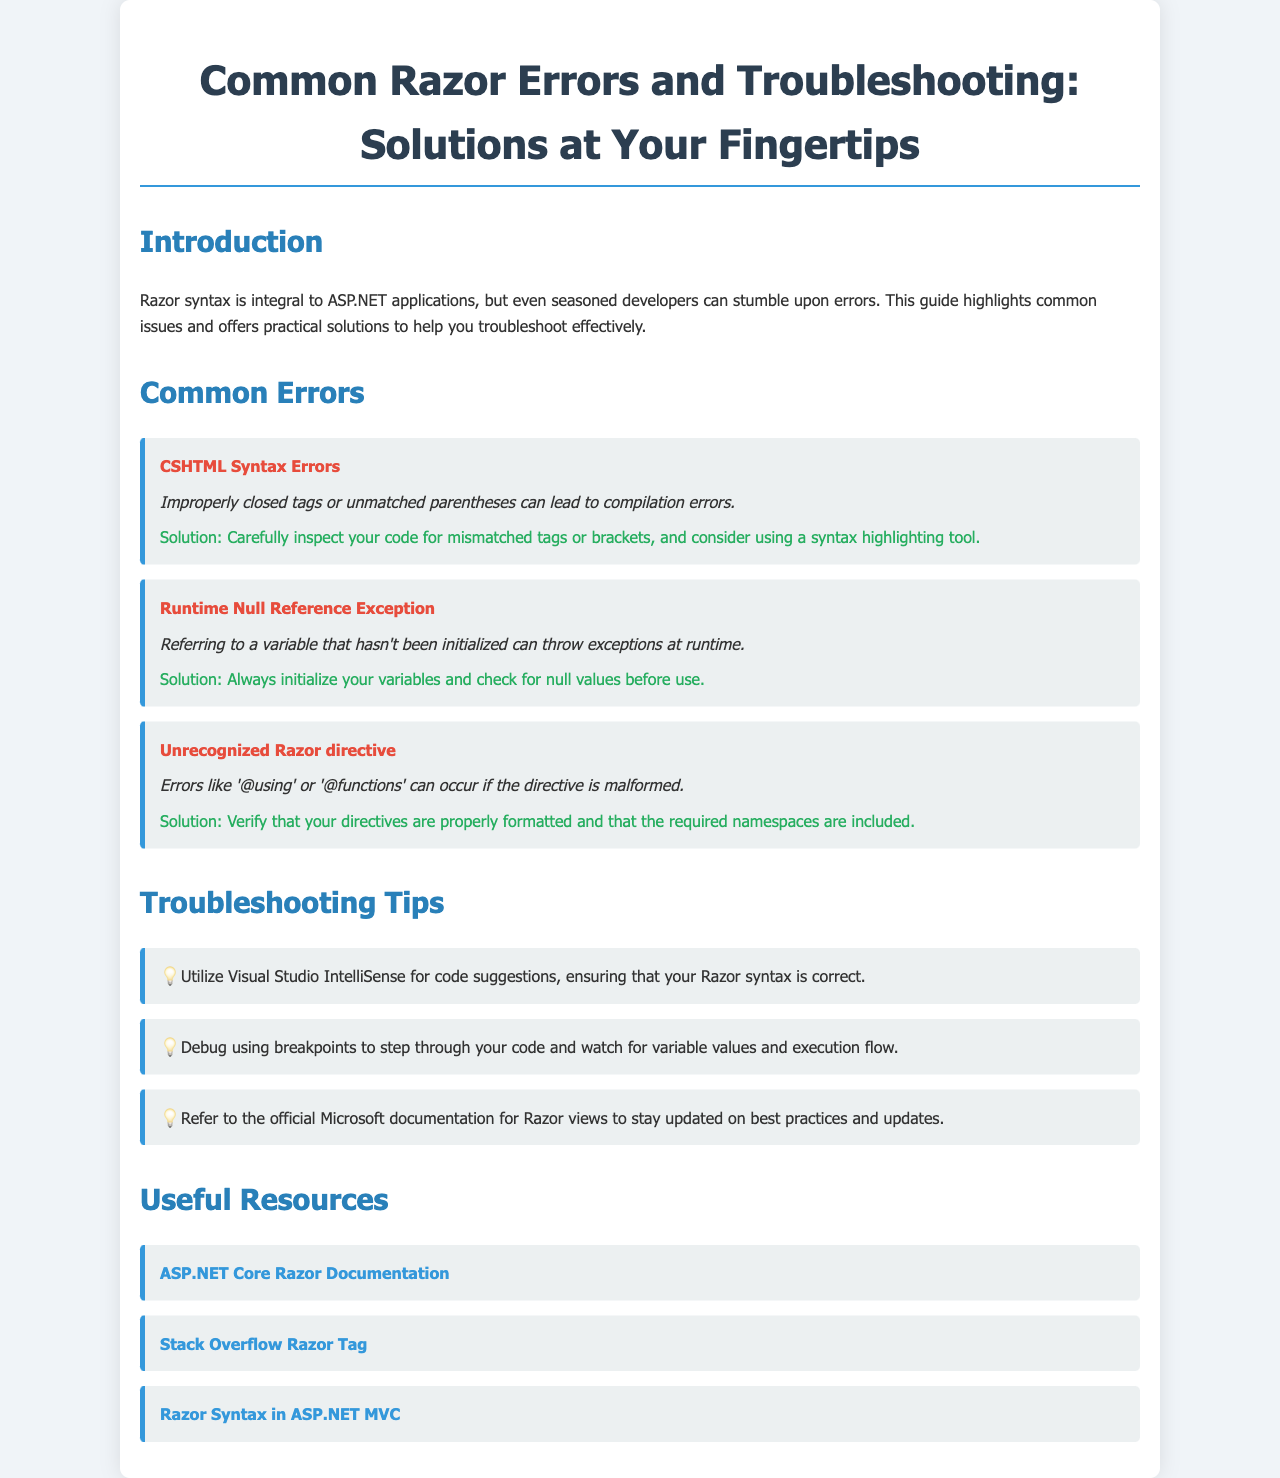What is the title of the brochure? The title is prominently displayed at the top of the document and summarizes the content covered.
Answer: Common Razor Errors and Troubleshooting: Solutions at Your Fingertips What is a common error related to CSHTML? The document lists specific errors under "Common Errors," including multiple examples.
Answer: CSHTML Syntax Errors What is a solution for a Runtime Null Reference Exception? The document suggests specific remedies for runtime errors, including variable management.
Answer: Always initialize your variables and check for null values before use What type of documentation is suggested for Razor views? The document refers to resources that provide further information and support for Razor syntax.
Answer: Official Microsoft documentation How many common errors are listed? The "Common Errors" section provides a specific number of errors discussed within the document.
Answer: Three What symbol is used to denote tips in the troubleshooting section? The document features a visual indicator for tips, enhancing readability and organization.
Answer: 💡 Which online platform is mentioned as a resource for Razor questions? The document lists several useful resources, among which one is a widely known platform.
Answer: Stack Overflow Razor Tag What is one troubleshooting tip provided in the document? The document outlines helpful suggestions for developers to improve their coding experience.
Answer: Utilize Visual Studio IntelliSense for code suggestions What color is used for the error title text? The document employs specific styling for emphasis on different content types, including errors.
Answer: Red 